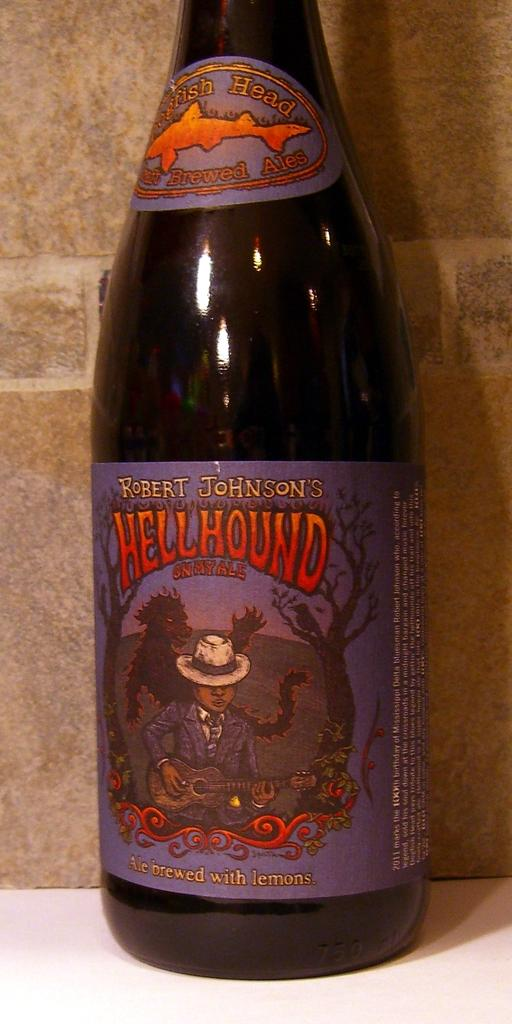Provide a one-sentence caption for the provided image. A bottle of Hellhound that was brewed with lemons sits on a counter. 